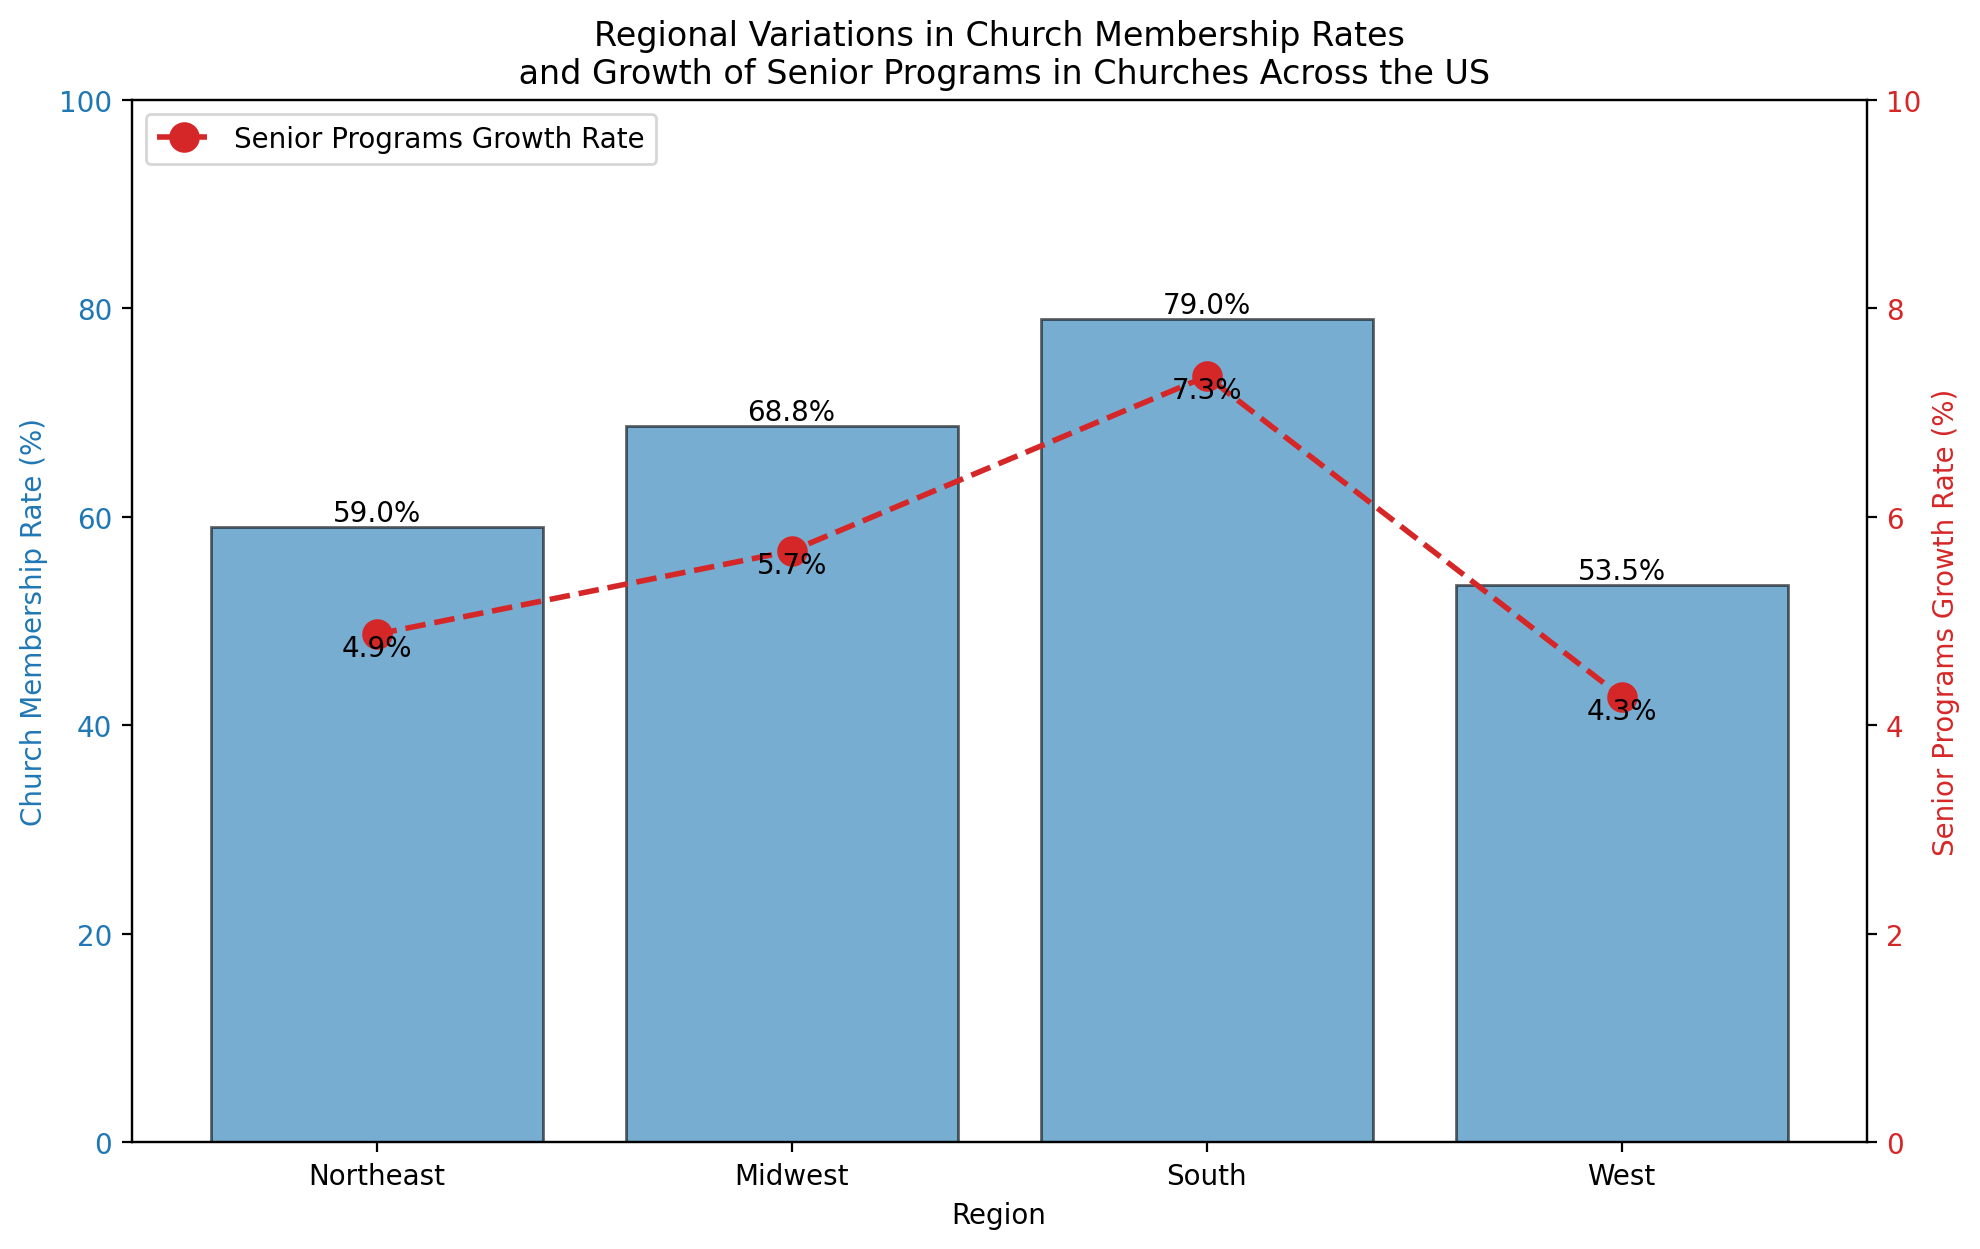What is the average Church Membership Rate across all regions? First, find the Church Membership Rates for all four regions: Northeast (59), Midwest (68.75), South (79), West (53.5). Add these values: 59 + 68.75 + 79 + 53.5 = 260.25. Then divide by the number of regions (4): 260.25 / 4 = 65.06.
Answer: 65.06% Which region has the highest Church Membership Rate? By comparing the averages, the South has the highest Church Membership Rate with an average of 79%.
Answer: South Which region has the lowest Senior Programs Growth Rate? By comparing the averages, the West has the lowest Senior Programs Growth Rate at 4.275%.
Answer: West Is there any region where the average Church Membership Rate is above 70%? Only the South (79%) and the Midwest (68.75%, but not over 70%) are close, but the South is clearly above 70%.
Answer: South How does the Senior Programs Growth Rate in the Northeast compare to the Midwest? The average Senior Programs Growth Rate in the Northeast is 4.875%, while in the Midwest, it is 5.675%. Compare these values to see that the Midwest has a higher growth rate.
Answer: Midwest What is the sum of the average Church Membership Rates in the Northeast and the West? The average Church Membership Rate in the Northeast is 59%, and in the West, it is 53.5%. Sum these values: 59 + 53.5 = 112.5.
Answer: 112.5 Which region shows the greatest variations between the Church Membership Rate and the Senior Programs Growth Rate? Calculate the difference for each region: Northeast (59 - 4.875 = 54.125), Midwest (68.75 - 5.675 = 63.075), South (79 - 7.375 = 71.625), West (53.5 - 4.275 = 49.225). The region with the largest difference is the South with a difference of 71.625.
Answer: South Do any regions have an average Senior Programs Growth Rate above 6%? The Senior Programs Growth Rate in the South is 7.375%, which is above 6%, while other regions are below 6%.
Answer: South 